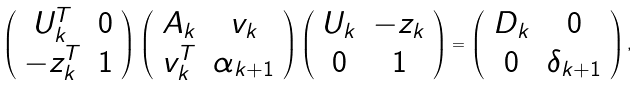Convert formula to latex. <formula><loc_0><loc_0><loc_500><loc_500>\left ( \begin{array} { c c } U _ { k } ^ { T } & 0 \\ - z _ { k } ^ { T } & 1 \\ \end{array} \right ) \left ( \begin{array} { c c } A _ { k } & v _ { k } \\ v _ { k } ^ { T } & \alpha _ { k + 1 } \\ \end{array} \right ) \left ( \begin{array} { c c } U _ { k } & - z _ { k } \\ 0 & 1 \\ \end{array} \right ) = \left ( \begin{array} { c c } D _ { k } & 0 \\ 0 & \delta _ { k + 1 } \\ \end{array} \right ) ,</formula> 